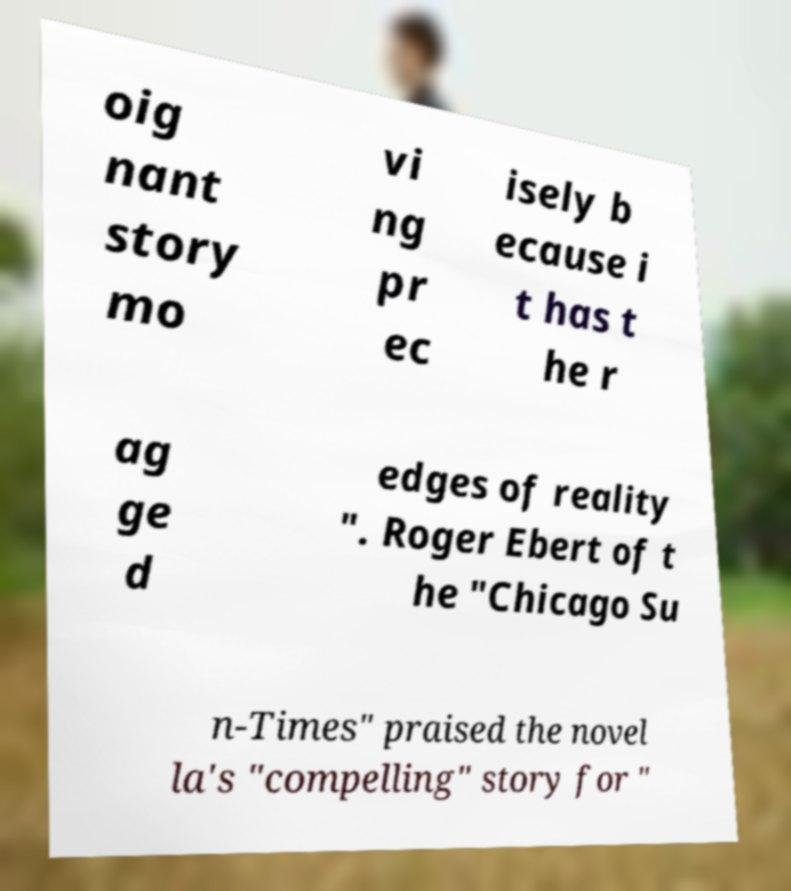Please read and relay the text visible in this image. What does it say? oig nant story mo vi ng pr ec isely b ecause i t has t he r ag ge d edges of reality ". Roger Ebert of t he "Chicago Su n-Times" praised the novel la's "compelling" story for " 